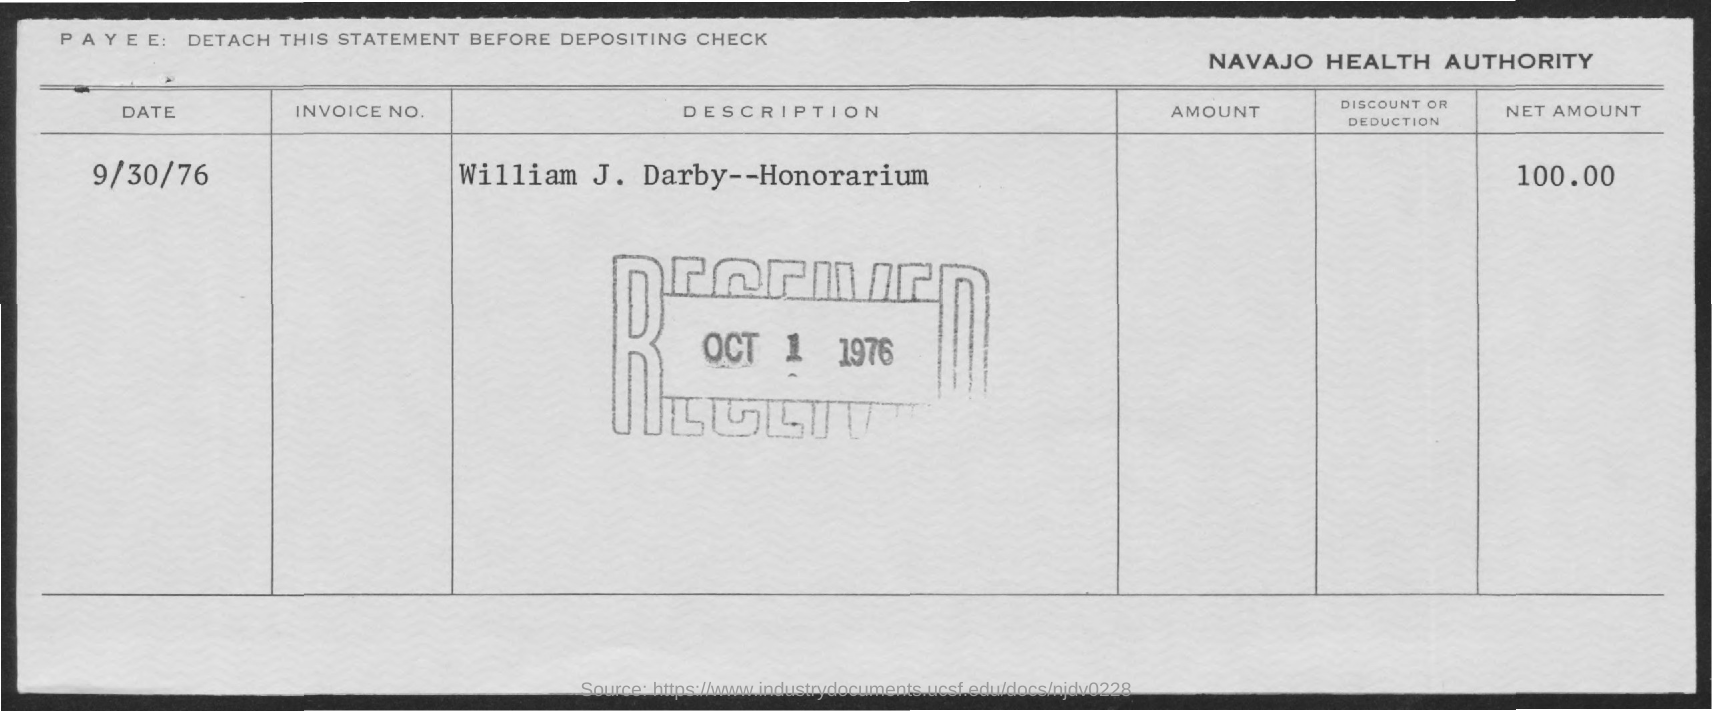Draw attention to some important aspects in this diagram. The total amount of honorarium is 100.00. On October 1, 1976, the honorarium was received. This honorarium is for William J. Darby. On what date was the honorarium given? September 30, 1976. 